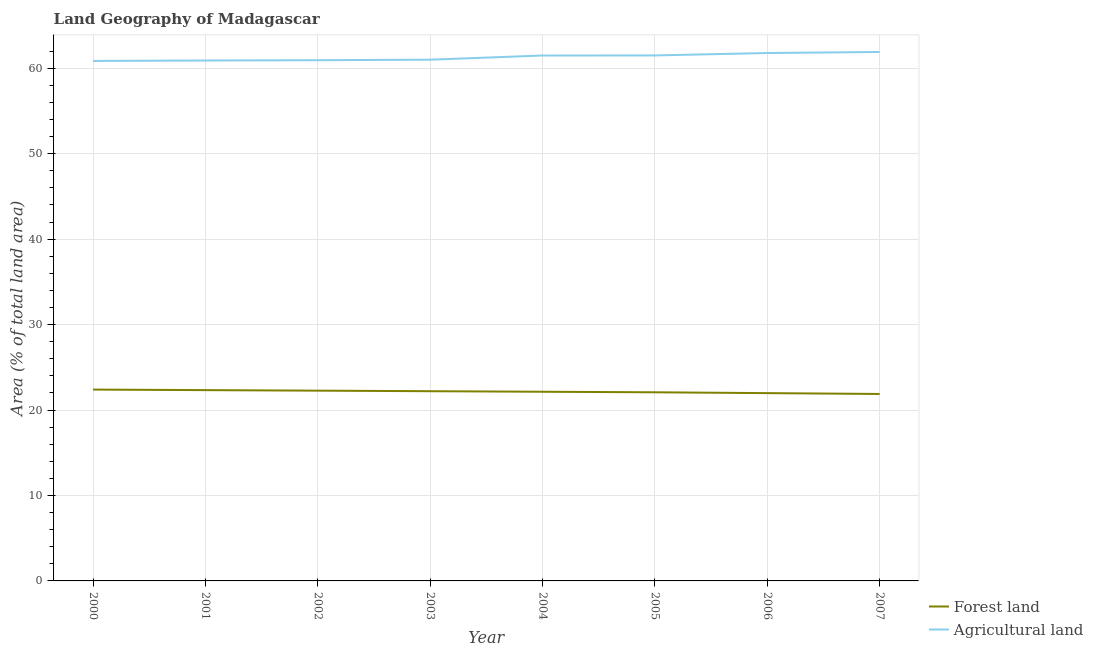How many different coloured lines are there?
Give a very brief answer. 2. Does the line corresponding to percentage of land area under agriculture intersect with the line corresponding to percentage of land area under forests?
Offer a very short reply. No. What is the percentage of land area under agriculture in 2001?
Ensure brevity in your answer.  60.91. Across all years, what is the maximum percentage of land area under agriculture?
Give a very brief answer. 61.9. Across all years, what is the minimum percentage of land area under agriculture?
Your answer should be compact. 60.86. In which year was the percentage of land area under agriculture maximum?
Ensure brevity in your answer.  2007. What is the total percentage of land area under forests in the graph?
Keep it short and to the point. 177.27. What is the difference between the percentage of land area under agriculture in 2004 and that in 2006?
Your answer should be compact. -0.29. What is the difference between the percentage of land area under agriculture in 2005 and the percentage of land area under forests in 2000?
Make the answer very short. 39.1. What is the average percentage of land area under forests per year?
Offer a very short reply. 22.16. In the year 2007, what is the difference between the percentage of land area under forests and percentage of land area under agriculture?
Keep it short and to the point. -40.02. In how many years, is the percentage of land area under forests greater than 48 %?
Your answer should be compact. 0. What is the ratio of the percentage of land area under agriculture in 2005 to that in 2006?
Your answer should be very brief. 1. Is the percentage of land area under forests in 2002 less than that in 2005?
Your answer should be very brief. No. Is the difference between the percentage of land area under forests in 2002 and 2005 greater than the difference between the percentage of land area under agriculture in 2002 and 2005?
Offer a terse response. Yes. What is the difference between the highest and the second highest percentage of land area under agriculture?
Make the answer very short. 0.12. What is the difference between the highest and the lowest percentage of land area under forests?
Ensure brevity in your answer.  0.51. Is the sum of the percentage of land area under forests in 2003 and 2006 greater than the maximum percentage of land area under agriculture across all years?
Offer a very short reply. No. Does the percentage of land area under forests monotonically increase over the years?
Offer a terse response. No. Is the percentage of land area under forests strictly less than the percentage of land area under agriculture over the years?
Make the answer very short. Yes. How many lines are there?
Ensure brevity in your answer.  2. Does the graph contain any zero values?
Offer a very short reply. No. How many legend labels are there?
Offer a terse response. 2. How are the legend labels stacked?
Your answer should be compact. Vertical. What is the title of the graph?
Provide a succinct answer. Land Geography of Madagascar. What is the label or title of the X-axis?
Your response must be concise. Year. What is the label or title of the Y-axis?
Provide a succinct answer. Area (% of total land area). What is the Area (% of total land area) of Forest land in 2000?
Keep it short and to the point. 22.39. What is the Area (% of total land area) in Agricultural land in 2000?
Ensure brevity in your answer.  60.86. What is the Area (% of total land area) of Forest land in 2001?
Offer a terse response. 22.33. What is the Area (% of total land area) in Agricultural land in 2001?
Keep it short and to the point. 60.91. What is the Area (% of total land area) of Forest land in 2002?
Give a very brief answer. 22.27. What is the Area (% of total land area) of Agricultural land in 2002?
Make the answer very short. 60.94. What is the Area (% of total land area) in Forest land in 2003?
Offer a terse response. 22.2. What is the Area (% of total land area) of Agricultural land in 2003?
Make the answer very short. 61. What is the Area (% of total land area) of Forest land in 2004?
Provide a short and direct response. 22.14. What is the Area (% of total land area) of Agricultural land in 2004?
Your answer should be compact. 61.49. What is the Area (% of total land area) of Forest land in 2005?
Ensure brevity in your answer.  22.08. What is the Area (% of total land area) in Agricultural land in 2005?
Offer a terse response. 61.5. What is the Area (% of total land area) in Forest land in 2006?
Give a very brief answer. 21.98. What is the Area (% of total land area) in Agricultural land in 2006?
Make the answer very short. 61.78. What is the Area (% of total land area) of Forest land in 2007?
Give a very brief answer. 21.88. What is the Area (% of total land area) of Agricultural land in 2007?
Keep it short and to the point. 61.9. Across all years, what is the maximum Area (% of total land area) of Forest land?
Provide a short and direct response. 22.39. Across all years, what is the maximum Area (% of total land area) in Agricultural land?
Offer a very short reply. 61.9. Across all years, what is the minimum Area (% of total land area) in Forest land?
Offer a very short reply. 21.88. Across all years, what is the minimum Area (% of total land area) in Agricultural land?
Your answer should be compact. 60.86. What is the total Area (% of total land area) in Forest land in the graph?
Make the answer very short. 177.27. What is the total Area (% of total land area) in Agricultural land in the graph?
Offer a terse response. 490.38. What is the difference between the Area (% of total land area) of Forest land in 2000 and that in 2001?
Ensure brevity in your answer.  0.06. What is the difference between the Area (% of total land area) of Agricultural land in 2000 and that in 2001?
Keep it short and to the point. -0.05. What is the difference between the Area (% of total land area) in Forest land in 2000 and that in 2002?
Offer a terse response. 0.13. What is the difference between the Area (% of total land area) in Agricultural land in 2000 and that in 2002?
Your answer should be compact. -0.09. What is the difference between the Area (% of total land area) in Forest land in 2000 and that in 2003?
Keep it short and to the point. 0.19. What is the difference between the Area (% of total land area) of Agricultural land in 2000 and that in 2003?
Your answer should be compact. -0.15. What is the difference between the Area (% of total land area) of Forest land in 2000 and that in 2004?
Provide a short and direct response. 0.25. What is the difference between the Area (% of total land area) in Agricultural land in 2000 and that in 2004?
Keep it short and to the point. -0.63. What is the difference between the Area (% of total land area) of Forest land in 2000 and that in 2005?
Ensure brevity in your answer.  0.32. What is the difference between the Area (% of total land area) of Agricultural land in 2000 and that in 2005?
Your answer should be compact. -0.64. What is the difference between the Area (% of total land area) in Forest land in 2000 and that in 2006?
Provide a succinct answer. 0.42. What is the difference between the Area (% of total land area) of Agricultural land in 2000 and that in 2006?
Make the answer very short. -0.93. What is the difference between the Area (% of total land area) in Forest land in 2000 and that in 2007?
Keep it short and to the point. 0.51. What is the difference between the Area (% of total land area) in Agricultural land in 2000 and that in 2007?
Your response must be concise. -1.05. What is the difference between the Area (% of total land area) in Forest land in 2001 and that in 2002?
Provide a succinct answer. 0.06. What is the difference between the Area (% of total land area) in Agricultural land in 2001 and that in 2002?
Provide a short and direct response. -0.03. What is the difference between the Area (% of total land area) in Forest land in 2001 and that in 2003?
Give a very brief answer. 0.13. What is the difference between the Area (% of total land area) in Agricultural land in 2001 and that in 2003?
Ensure brevity in your answer.  -0.09. What is the difference between the Area (% of total land area) in Forest land in 2001 and that in 2004?
Your response must be concise. 0.19. What is the difference between the Area (% of total land area) in Agricultural land in 2001 and that in 2004?
Your answer should be compact. -0.58. What is the difference between the Area (% of total land area) of Forest land in 2001 and that in 2005?
Provide a succinct answer. 0.25. What is the difference between the Area (% of total land area) in Agricultural land in 2001 and that in 2005?
Your answer should be very brief. -0.59. What is the difference between the Area (% of total land area) of Forest land in 2001 and that in 2006?
Your answer should be very brief. 0.35. What is the difference between the Area (% of total land area) of Agricultural land in 2001 and that in 2006?
Your answer should be very brief. -0.88. What is the difference between the Area (% of total land area) in Forest land in 2001 and that in 2007?
Make the answer very short. 0.45. What is the difference between the Area (% of total land area) in Agricultural land in 2001 and that in 2007?
Offer a very short reply. -1. What is the difference between the Area (% of total land area) of Forest land in 2002 and that in 2003?
Provide a succinct answer. 0.06. What is the difference between the Area (% of total land area) of Agricultural land in 2002 and that in 2003?
Ensure brevity in your answer.  -0.06. What is the difference between the Area (% of total land area) of Forest land in 2002 and that in 2004?
Offer a very short reply. 0.13. What is the difference between the Area (% of total land area) of Agricultural land in 2002 and that in 2004?
Give a very brief answer. -0.55. What is the difference between the Area (% of total land area) of Forest land in 2002 and that in 2005?
Make the answer very short. 0.19. What is the difference between the Area (% of total land area) of Agricultural land in 2002 and that in 2005?
Your answer should be very brief. -0.56. What is the difference between the Area (% of total land area) of Forest land in 2002 and that in 2006?
Provide a short and direct response. 0.29. What is the difference between the Area (% of total land area) in Agricultural land in 2002 and that in 2006?
Offer a very short reply. -0.84. What is the difference between the Area (% of total land area) of Forest land in 2002 and that in 2007?
Ensure brevity in your answer.  0.39. What is the difference between the Area (% of total land area) in Agricultural land in 2002 and that in 2007?
Your answer should be compact. -0.96. What is the difference between the Area (% of total land area) of Forest land in 2003 and that in 2004?
Your answer should be compact. 0.06. What is the difference between the Area (% of total land area) of Agricultural land in 2003 and that in 2004?
Ensure brevity in your answer.  -0.49. What is the difference between the Area (% of total land area) in Forest land in 2003 and that in 2005?
Your response must be concise. 0.13. What is the difference between the Area (% of total land area) in Agricultural land in 2003 and that in 2005?
Make the answer very short. -0.5. What is the difference between the Area (% of total land area) of Forest land in 2003 and that in 2006?
Offer a terse response. 0.23. What is the difference between the Area (% of total land area) of Agricultural land in 2003 and that in 2006?
Offer a terse response. -0.78. What is the difference between the Area (% of total land area) of Forest land in 2003 and that in 2007?
Your answer should be compact. 0.32. What is the difference between the Area (% of total land area) of Agricultural land in 2003 and that in 2007?
Provide a succinct answer. -0.9. What is the difference between the Area (% of total land area) in Forest land in 2004 and that in 2005?
Offer a very short reply. 0.06. What is the difference between the Area (% of total land area) in Agricultural land in 2004 and that in 2005?
Your answer should be compact. -0.01. What is the difference between the Area (% of total land area) in Forest land in 2004 and that in 2006?
Provide a succinct answer. 0.16. What is the difference between the Area (% of total land area) of Agricultural land in 2004 and that in 2006?
Give a very brief answer. -0.29. What is the difference between the Area (% of total land area) in Forest land in 2004 and that in 2007?
Keep it short and to the point. 0.26. What is the difference between the Area (% of total land area) in Agricultural land in 2004 and that in 2007?
Provide a short and direct response. -0.41. What is the difference between the Area (% of total land area) of Forest land in 2005 and that in 2006?
Your response must be concise. 0.1. What is the difference between the Area (% of total land area) of Agricultural land in 2005 and that in 2006?
Provide a succinct answer. -0.28. What is the difference between the Area (% of total land area) in Forest land in 2005 and that in 2007?
Offer a very short reply. 0.2. What is the difference between the Area (% of total land area) of Agricultural land in 2005 and that in 2007?
Your response must be concise. -0.41. What is the difference between the Area (% of total land area) in Forest land in 2006 and that in 2007?
Offer a terse response. 0.1. What is the difference between the Area (% of total land area) in Agricultural land in 2006 and that in 2007?
Give a very brief answer. -0.12. What is the difference between the Area (% of total land area) of Forest land in 2000 and the Area (% of total land area) of Agricultural land in 2001?
Offer a terse response. -38.51. What is the difference between the Area (% of total land area) in Forest land in 2000 and the Area (% of total land area) in Agricultural land in 2002?
Give a very brief answer. -38.55. What is the difference between the Area (% of total land area) of Forest land in 2000 and the Area (% of total land area) of Agricultural land in 2003?
Make the answer very short. -38.61. What is the difference between the Area (% of total land area) of Forest land in 2000 and the Area (% of total land area) of Agricultural land in 2004?
Keep it short and to the point. -39.1. What is the difference between the Area (% of total land area) of Forest land in 2000 and the Area (% of total land area) of Agricultural land in 2005?
Provide a succinct answer. -39.1. What is the difference between the Area (% of total land area) in Forest land in 2000 and the Area (% of total land area) in Agricultural land in 2006?
Make the answer very short. -39.39. What is the difference between the Area (% of total land area) of Forest land in 2000 and the Area (% of total land area) of Agricultural land in 2007?
Provide a succinct answer. -39.51. What is the difference between the Area (% of total land area) in Forest land in 2001 and the Area (% of total land area) in Agricultural land in 2002?
Keep it short and to the point. -38.61. What is the difference between the Area (% of total land area) of Forest land in 2001 and the Area (% of total land area) of Agricultural land in 2003?
Make the answer very short. -38.67. What is the difference between the Area (% of total land area) of Forest land in 2001 and the Area (% of total land area) of Agricultural land in 2004?
Your response must be concise. -39.16. What is the difference between the Area (% of total land area) of Forest land in 2001 and the Area (% of total land area) of Agricultural land in 2005?
Your answer should be compact. -39.17. What is the difference between the Area (% of total land area) in Forest land in 2001 and the Area (% of total land area) in Agricultural land in 2006?
Offer a very short reply. -39.45. What is the difference between the Area (% of total land area) of Forest land in 2001 and the Area (% of total land area) of Agricultural land in 2007?
Ensure brevity in your answer.  -39.57. What is the difference between the Area (% of total land area) of Forest land in 2002 and the Area (% of total land area) of Agricultural land in 2003?
Your answer should be very brief. -38.74. What is the difference between the Area (% of total land area) in Forest land in 2002 and the Area (% of total land area) in Agricultural land in 2004?
Make the answer very short. -39.22. What is the difference between the Area (% of total land area) of Forest land in 2002 and the Area (% of total land area) of Agricultural land in 2005?
Offer a very short reply. -39.23. What is the difference between the Area (% of total land area) in Forest land in 2002 and the Area (% of total land area) in Agricultural land in 2006?
Offer a very short reply. -39.52. What is the difference between the Area (% of total land area) of Forest land in 2002 and the Area (% of total land area) of Agricultural land in 2007?
Offer a very short reply. -39.64. What is the difference between the Area (% of total land area) of Forest land in 2003 and the Area (% of total land area) of Agricultural land in 2004?
Give a very brief answer. -39.29. What is the difference between the Area (% of total land area) of Forest land in 2003 and the Area (% of total land area) of Agricultural land in 2005?
Provide a succinct answer. -39.3. What is the difference between the Area (% of total land area) of Forest land in 2003 and the Area (% of total land area) of Agricultural land in 2006?
Offer a very short reply. -39.58. What is the difference between the Area (% of total land area) of Forest land in 2003 and the Area (% of total land area) of Agricultural land in 2007?
Make the answer very short. -39.7. What is the difference between the Area (% of total land area) in Forest land in 2004 and the Area (% of total land area) in Agricultural land in 2005?
Ensure brevity in your answer.  -39.36. What is the difference between the Area (% of total land area) in Forest land in 2004 and the Area (% of total land area) in Agricultural land in 2006?
Provide a short and direct response. -39.64. What is the difference between the Area (% of total land area) in Forest land in 2004 and the Area (% of total land area) in Agricultural land in 2007?
Provide a succinct answer. -39.77. What is the difference between the Area (% of total land area) in Forest land in 2005 and the Area (% of total land area) in Agricultural land in 2006?
Ensure brevity in your answer.  -39.71. What is the difference between the Area (% of total land area) of Forest land in 2005 and the Area (% of total land area) of Agricultural land in 2007?
Offer a terse response. -39.83. What is the difference between the Area (% of total land area) in Forest land in 2006 and the Area (% of total land area) in Agricultural land in 2007?
Keep it short and to the point. -39.93. What is the average Area (% of total land area) in Forest land per year?
Keep it short and to the point. 22.16. What is the average Area (% of total land area) in Agricultural land per year?
Your answer should be compact. 61.3. In the year 2000, what is the difference between the Area (% of total land area) of Forest land and Area (% of total land area) of Agricultural land?
Offer a very short reply. -38.46. In the year 2001, what is the difference between the Area (% of total land area) in Forest land and Area (% of total land area) in Agricultural land?
Offer a terse response. -38.58. In the year 2002, what is the difference between the Area (% of total land area) in Forest land and Area (% of total land area) in Agricultural land?
Provide a succinct answer. -38.67. In the year 2003, what is the difference between the Area (% of total land area) in Forest land and Area (% of total land area) in Agricultural land?
Your answer should be compact. -38.8. In the year 2004, what is the difference between the Area (% of total land area) in Forest land and Area (% of total land area) in Agricultural land?
Offer a very short reply. -39.35. In the year 2005, what is the difference between the Area (% of total land area) in Forest land and Area (% of total land area) in Agricultural land?
Your answer should be compact. -39.42. In the year 2006, what is the difference between the Area (% of total land area) in Forest land and Area (% of total land area) in Agricultural land?
Ensure brevity in your answer.  -39.8. In the year 2007, what is the difference between the Area (% of total land area) of Forest land and Area (% of total land area) of Agricultural land?
Give a very brief answer. -40.02. What is the ratio of the Area (% of total land area) in Forest land in 2000 to that in 2003?
Make the answer very short. 1.01. What is the ratio of the Area (% of total land area) of Forest land in 2000 to that in 2004?
Your answer should be very brief. 1.01. What is the ratio of the Area (% of total land area) of Agricultural land in 2000 to that in 2004?
Provide a short and direct response. 0.99. What is the ratio of the Area (% of total land area) in Forest land in 2000 to that in 2005?
Provide a succinct answer. 1.01. What is the ratio of the Area (% of total land area) in Forest land in 2000 to that in 2006?
Your answer should be compact. 1.02. What is the ratio of the Area (% of total land area) in Agricultural land in 2000 to that in 2006?
Keep it short and to the point. 0.98. What is the ratio of the Area (% of total land area) in Forest land in 2000 to that in 2007?
Give a very brief answer. 1.02. What is the ratio of the Area (% of total land area) of Agricultural land in 2000 to that in 2007?
Keep it short and to the point. 0.98. What is the ratio of the Area (% of total land area) in Agricultural land in 2001 to that in 2002?
Offer a terse response. 1. What is the ratio of the Area (% of total land area) in Forest land in 2001 to that in 2004?
Give a very brief answer. 1.01. What is the ratio of the Area (% of total land area) of Forest land in 2001 to that in 2005?
Offer a terse response. 1.01. What is the ratio of the Area (% of total land area) in Forest land in 2001 to that in 2006?
Keep it short and to the point. 1.02. What is the ratio of the Area (% of total land area) of Agricultural land in 2001 to that in 2006?
Keep it short and to the point. 0.99. What is the ratio of the Area (% of total land area) in Forest land in 2001 to that in 2007?
Your answer should be very brief. 1.02. What is the ratio of the Area (% of total land area) in Agricultural land in 2001 to that in 2007?
Keep it short and to the point. 0.98. What is the ratio of the Area (% of total land area) in Agricultural land in 2002 to that in 2004?
Your answer should be compact. 0.99. What is the ratio of the Area (% of total land area) of Forest land in 2002 to that in 2005?
Your answer should be very brief. 1.01. What is the ratio of the Area (% of total land area) in Agricultural land in 2002 to that in 2005?
Ensure brevity in your answer.  0.99. What is the ratio of the Area (% of total land area) of Forest land in 2002 to that in 2006?
Ensure brevity in your answer.  1.01. What is the ratio of the Area (% of total land area) of Agricultural land in 2002 to that in 2006?
Your answer should be very brief. 0.99. What is the ratio of the Area (% of total land area) of Forest land in 2002 to that in 2007?
Provide a succinct answer. 1.02. What is the ratio of the Area (% of total land area) in Agricultural land in 2002 to that in 2007?
Keep it short and to the point. 0.98. What is the ratio of the Area (% of total land area) in Forest land in 2003 to that in 2004?
Your response must be concise. 1. What is the ratio of the Area (% of total land area) of Forest land in 2003 to that in 2005?
Ensure brevity in your answer.  1.01. What is the ratio of the Area (% of total land area) of Forest land in 2003 to that in 2006?
Make the answer very short. 1.01. What is the ratio of the Area (% of total land area) in Agricultural land in 2003 to that in 2006?
Keep it short and to the point. 0.99. What is the ratio of the Area (% of total land area) in Forest land in 2003 to that in 2007?
Offer a very short reply. 1.01. What is the ratio of the Area (% of total land area) in Agricultural land in 2003 to that in 2007?
Offer a terse response. 0.99. What is the ratio of the Area (% of total land area) in Forest land in 2004 to that in 2005?
Your answer should be very brief. 1. What is the ratio of the Area (% of total land area) of Forest land in 2004 to that in 2006?
Provide a succinct answer. 1.01. What is the ratio of the Area (% of total land area) in Forest land in 2004 to that in 2007?
Your answer should be compact. 1.01. What is the ratio of the Area (% of total land area) in Agricultural land in 2004 to that in 2007?
Ensure brevity in your answer.  0.99. What is the ratio of the Area (% of total land area) in Agricultural land in 2005 to that in 2006?
Your answer should be very brief. 1. What is the ratio of the Area (% of total land area) of Agricultural land in 2005 to that in 2007?
Your response must be concise. 0.99. What is the difference between the highest and the second highest Area (% of total land area) in Forest land?
Offer a very short reply. 0.06. What is the difference between the highest and the second highest Area (% of total land area) in Agricultural land?
Provide a succinct answer. 0.12. What is the difference between the highest and the lowest Area (% of total land area) in Forest land?
Give a very brief answer. 0.51. What is the difference between the highest and the lowest Area (% of total land area) in Agricultural land?
Offer a terse response. 1.05. 